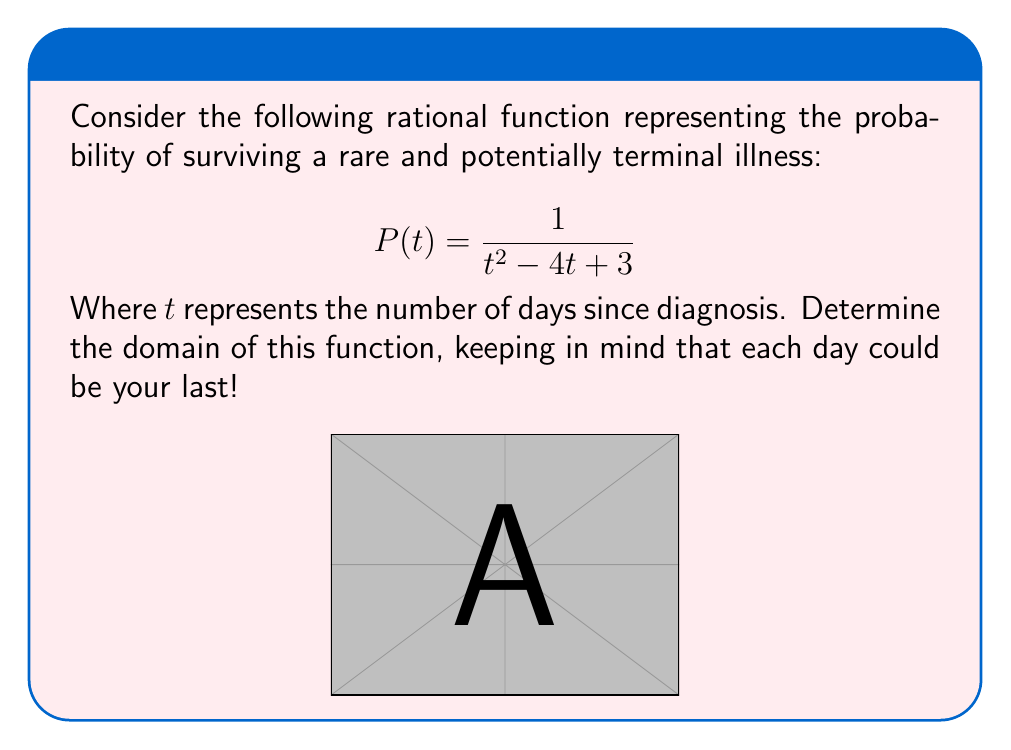Can you solve this math problem? Let's approach this step-by-step, with the gravity it deserves:

1) The domain of a rational function includes all real numbers except those that make the denominator equal to zero.

2) We need to find the values of $t$ that make the denominator zero:
   $$t^2 - 4t + 3 = 0$$

3) This is a quadratic equation. We can solve it using the quadratic formula:
   $$t = \frac{-b \pm \sqrt{b^2 - 4ac}}{2a}$$
   Where $a=1$, $b=-4$, and $c=3$

4) Substituting these values:
   $$t = \frac{4 \pm \sqrt{16 - 12}}{2} = \frac{4 \pm \sqrt{4}}{2} = \frac{4 \pm 2}{2}$$

5) This gives us two solutions:
   $$t = \frac{4 + 2}{2} = 3$$ or $$t = \frac{4 - 2}{2} = 1$$

6) The function is undefined when $t = 1$ or $t = 3$.

7) Therefore, the domain of $P(t)$ is all real numbers except 1 and 3.

In set notation, this is written as: $\{t \in \mathbb{R} : t \neq 1 \text{ and } t \neq 3\}$
Answer: $\{t \in \mathbb{R} : t \neq 1 \text{ and } t \neq 3\}$ 